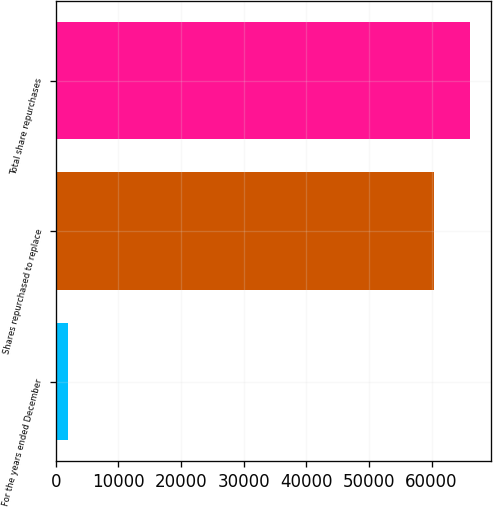<chart> <loc_0><loc_0><loc_500><loc_500><bar_chart><fcel>For the years ended December<fcel>Shares repurchased to replace<fcel>Total share repurchases<nl><fcel>2008<fcel>60361<fcel>66196.3<nl></chart> 